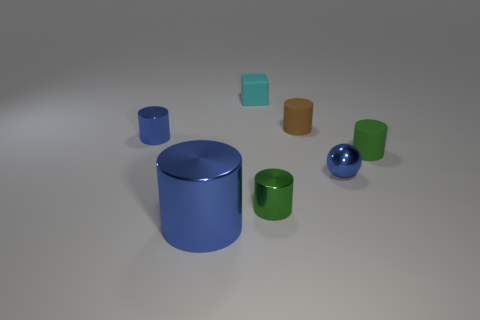Subtract all green cylinders. How many were subtracted if there are1green cylinders left? 1 Subtract all blocks. How many objects are left? 6 Subtract 1 spheres. How many spheres are left? 0 Subtract all brown balls. Subtract all cyan blocks. How many balls are left? 1 Subtract all blue balls. How many blue cylinders are left? 2 Subtract all big cyan metallic things. Subtract all tiny objects. How many objects are left? 1 Add 6 brown objects. How many brown objects are left? 7 Add 6 matte objects. How many matte objects exist? 9 Add 1 small rubber blocks. How many objects exist? 8 Subtract all brown cylinders. How many cylinders are left? 4 